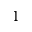Convert formula to latex. <formula><loc_0><loc_0><loc_500><loc_500>1</formula> 